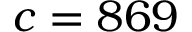Convert formula to latex. <formula><loc_0><loc_0><loc_500><loc_500>c = 8 6 9</formula> 